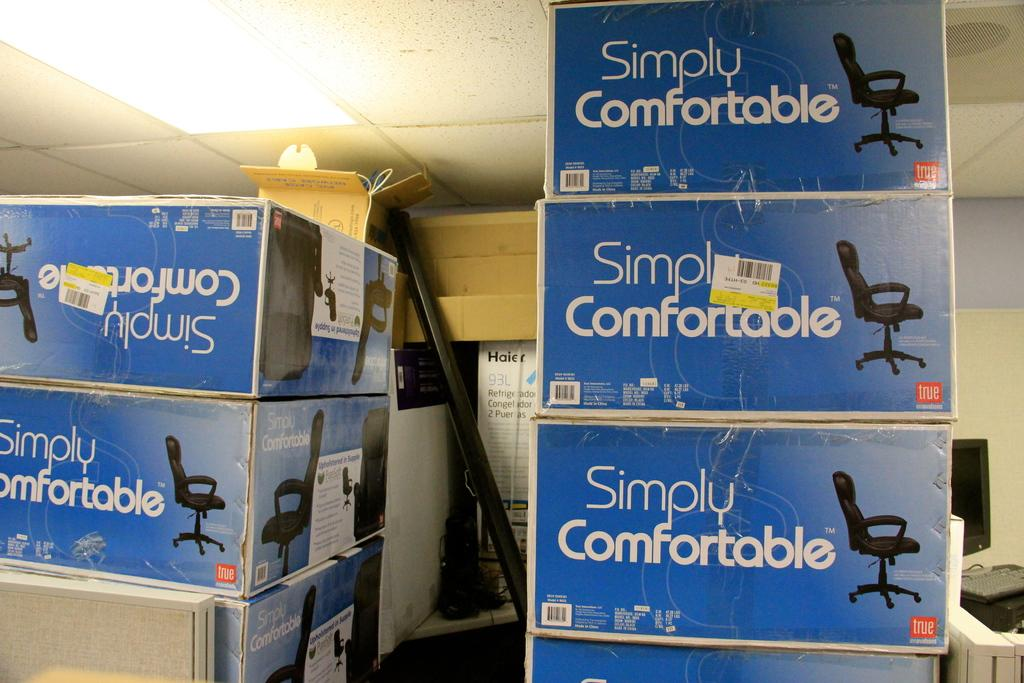<image>
Offer a succinct explanation of the picture presented. Simply Comfortable chairs in blue box's are stack high on one another 